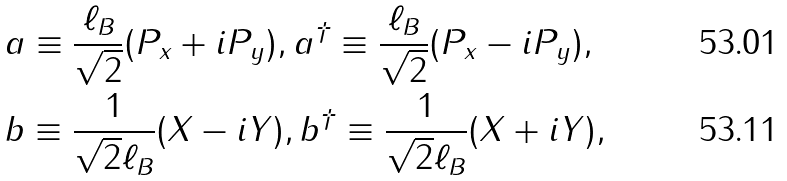Convert formula to latex. <formula><loc_0><loc_0><loc_500><loc_500>& a \equiv \frac { \ell _ { B } } { \sqrt { 2 } } ( P _ { x } + i P _ { y } ) , a ^ { \dagger } \equiv \frac { \ell _ { B } } { \sqrt { 2 } } ( P _ { x } - i P _ { y } ) , \\ & b \equiv \frac { 1 } { \sqrt { 2 } \ell _ { B } } ( X - i Y ) , b ^ { \dagger } \equiv \frac { 1 } { \sqrt { 2 } \ell _ { B } } ( X + i Y ) ,</formula> 